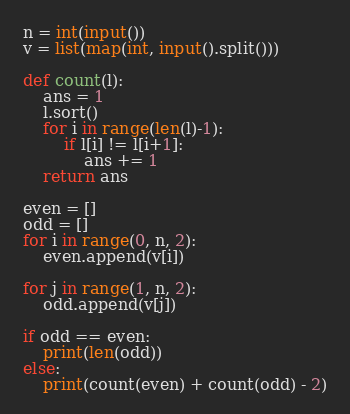Convert code to text. <code><loc_0><loc_0><loc_500><loc_500><_Python_>n = int(input())
v = list(map(int, input().split()))

def count(l):
    ans = 1
    l.sort()
    for i in range(len(l)-1):
        if l[i] != l[i+1]:
            ans += 1
    return ans

even = []
odd = []
for i in range(0, n, 2):
    even.append(v[i])
    
for j in range(1, n, 2):
    odd.append(v[j])
    
if odd == even:
    print(len(odd))
else:
    print(count(even) + count(odd) - 2)
</code> 